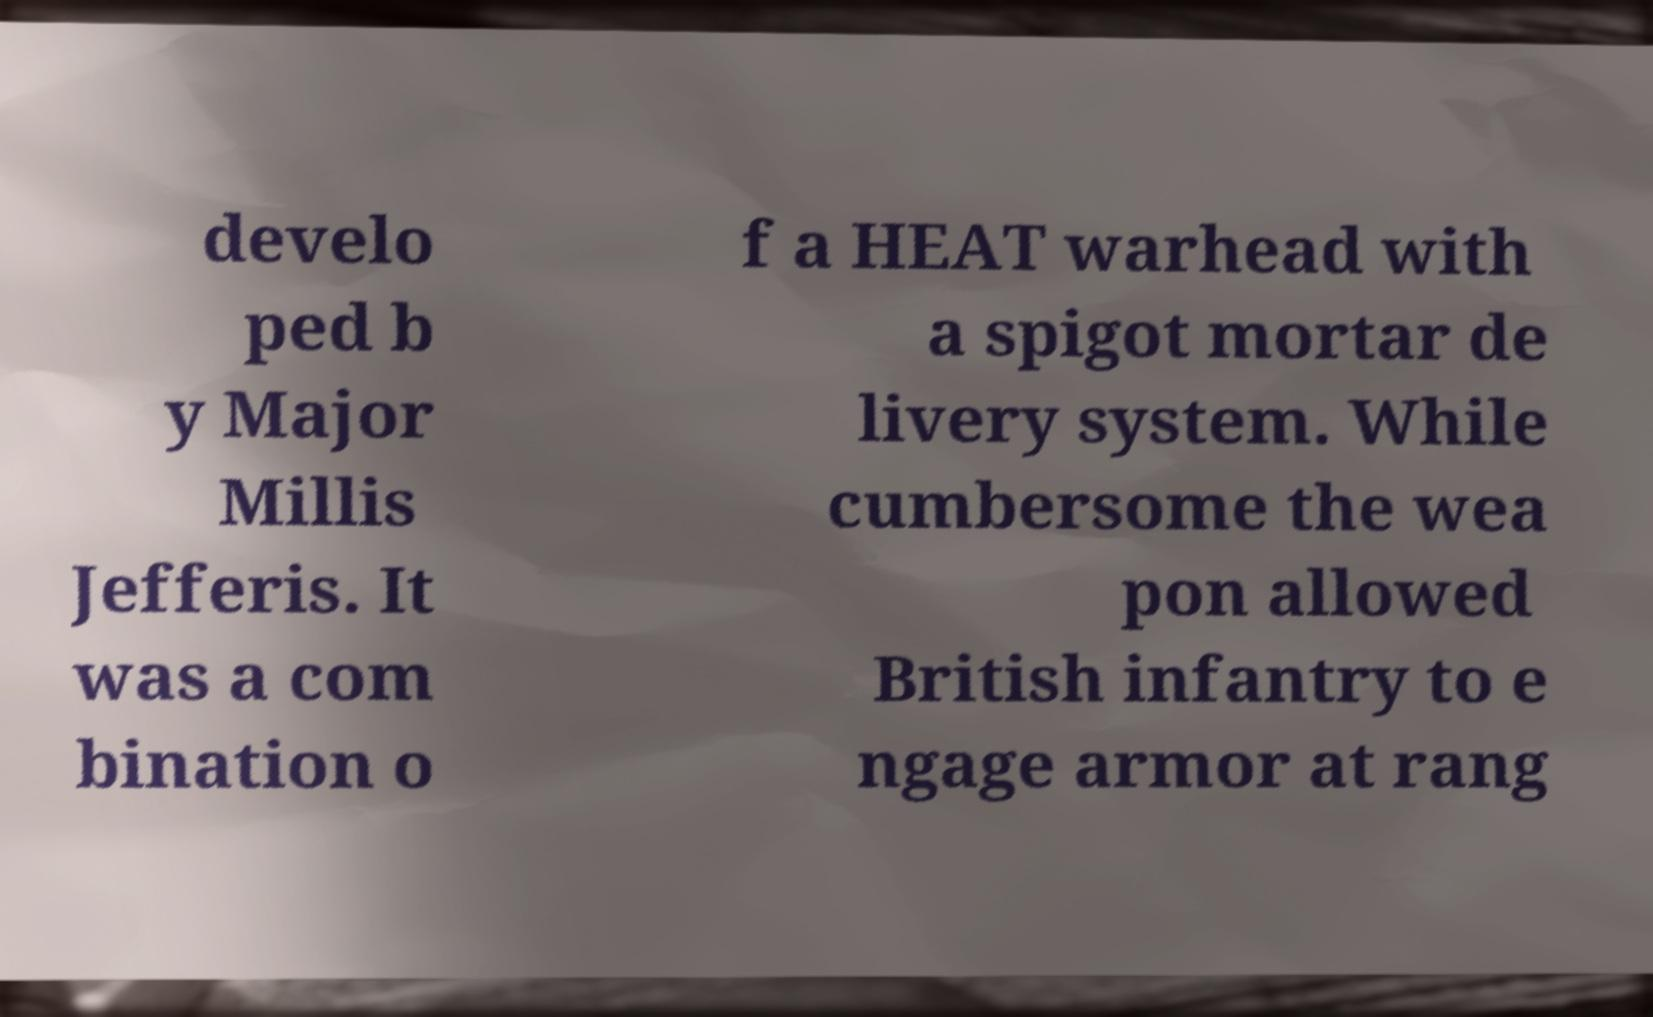Can you accurately transcribe the text from the provided image for me? develo ped b y Major Millis Jefferis. It was a com bination o f a HEAT warhead with a spigot mortar de livery system. While cumbersome the wea pon allowed British infantry to e ngage armor at rang 